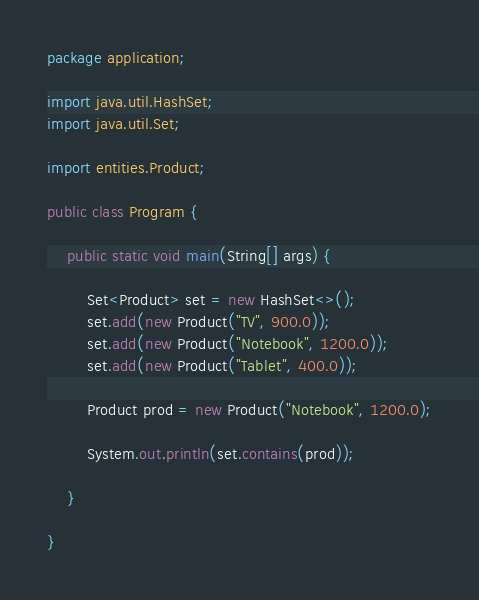Convert code to text. <code><loc_0><loc_0><loc_500><loc_500><_Java_>package application;

import java.util.HashSet;
import java.util.Set;

import entities.Product;

public class Program {
    
    public static void main(String[] args) {
        
        Set<Product> set = new HashSet<>();
        set.add(new Product("TV", 900.0));
        set.add(new Product("Notebook", 1200.0));
        set.add(new Product("Tablet", 400.0));

        Product prod = new Product("Notebook", 1200.0);
        
        System.out.println(set.contains(prod));
           
    }

}
</code> 